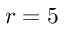Convert formula to latex. <formula><loc_0><loc_0><loc_500><loc_500>r = 5</formula> 